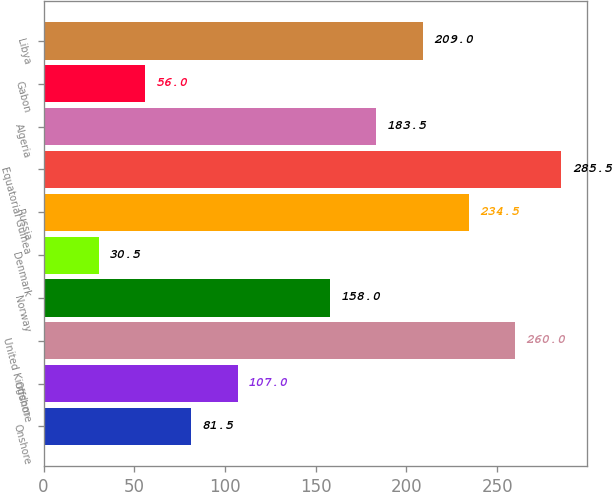<chart> <loc_0><loc_0><loc_500><loc_500><bar_chart><fcel>Onshore<fcel>Offshore<fcel>United Kingdom<fcel>Norway<fcel>Denmark<fcel>Russia<fcel>Equatorial Guinea<fcel>Algeria<fcel>Gabon<fcel>Libya<nl><fcel>81.5<fcel>107<fcel>260<fcel>158<fcel>30.5<fcel>234.5<fcel>285.5<fcel>183.5<fcel>56<fcel>209<nl></chart> 